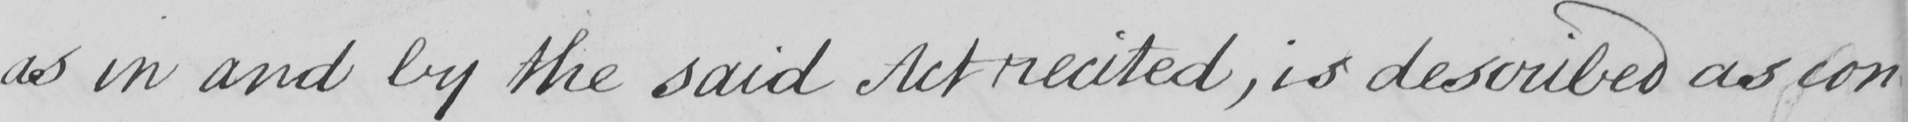Can you read and transcribe this handwriting? as in and by the said Act recited , is described as con- 